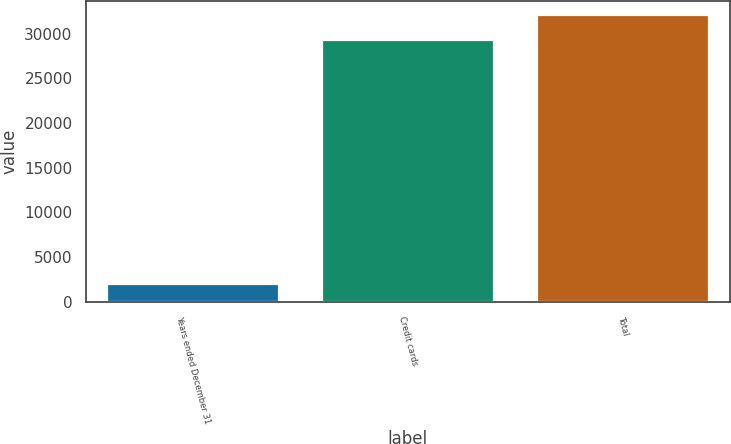Convert chart. <chart><loc_0><loc_0><loc_500><loc_500><bar_chart><fcel>Years ended December 31<fcel>Credit cards<fcel>Total<nl><fcel>2014<fcel>29313<fcel>32058.8<nl></chart> 